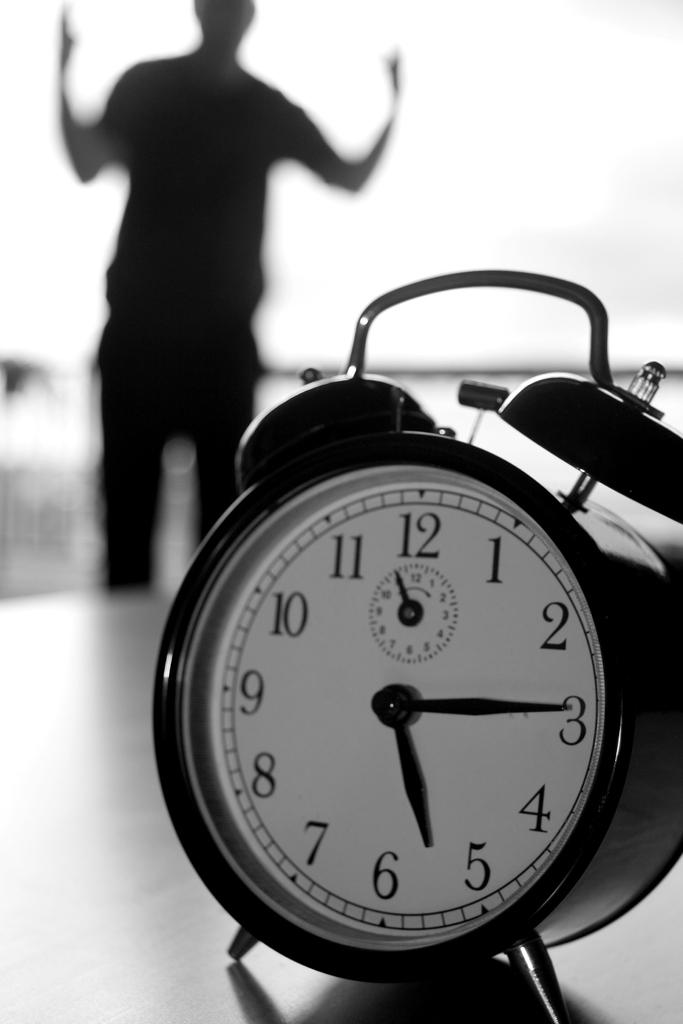<image>
Give a short and clear explanation of the subsequent image. A man standing near an alarm clock that is almost a quarter past 5. 